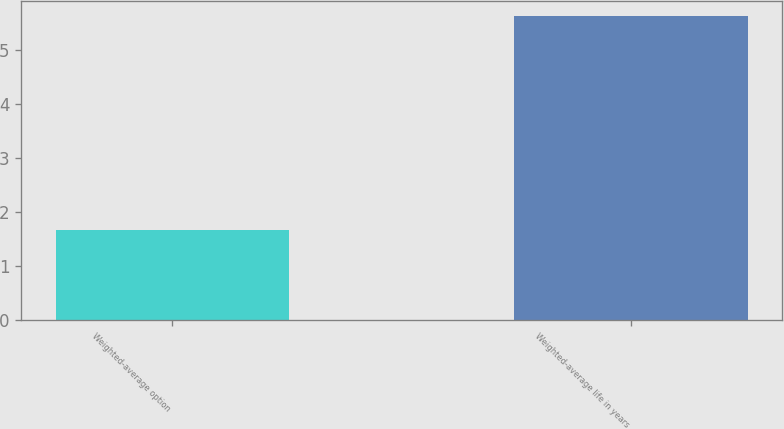<chart> <loc_0><loc_0><loc_500><loc_500><bar_chart><fcel>Weighted-average option<fcel>Weighted-average life in years<nl><fcel>1.67<fcel>5.62<nl></chart> 